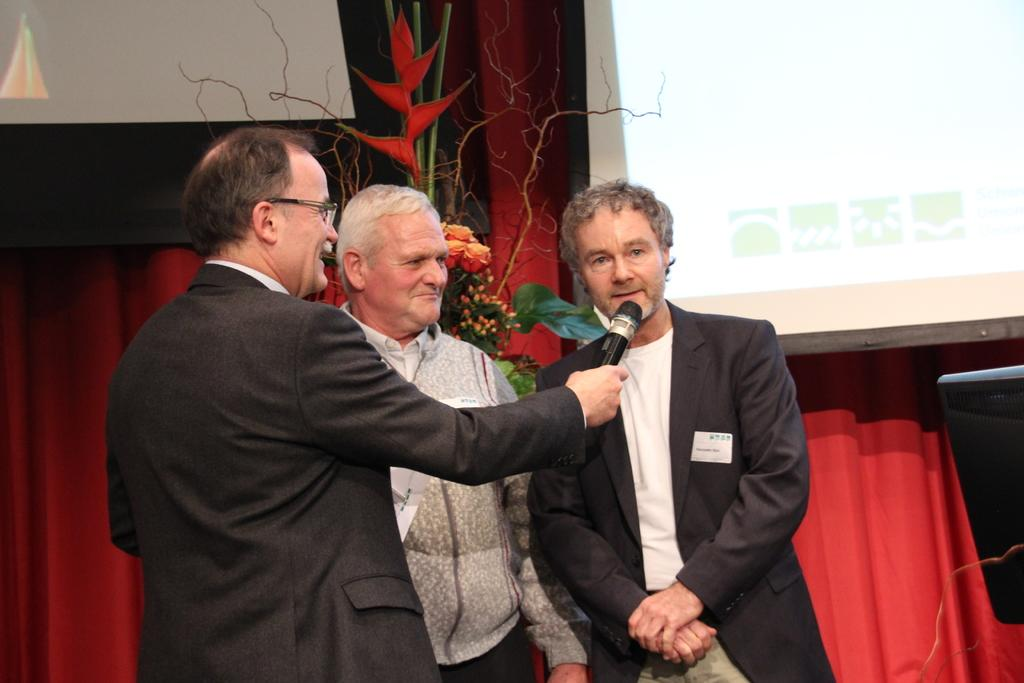How many people are present in the image? There are three people in the image. What is one person doing in the image? One person is holding a mic. What can be seen in the background of the image? There is a plant with flowers, a projector screen, and a curtain in the background. Where is the playground located in the image? There is no playground present in the image. What type of corn is growing near the plant with flowers? There is no corn present in the image. 